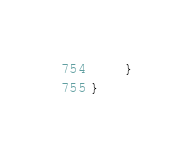Convert code to text. <code><loc_0><loc_0><loc_500><loc_500><_C++_>	}
}
</code> 